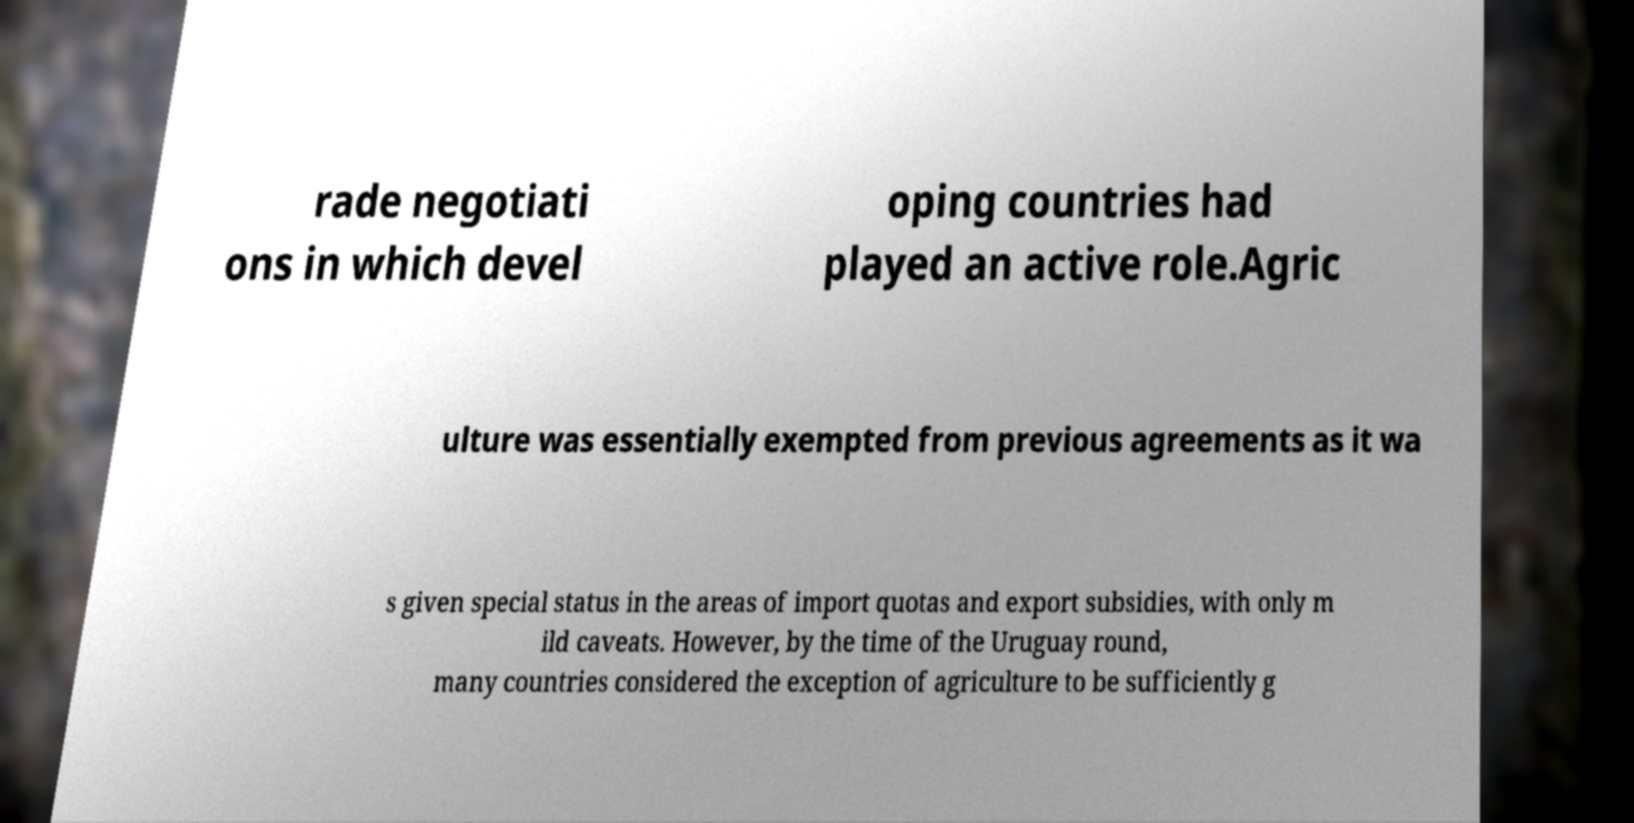I need the written content from this picture converted into text. Can you do that? rade negotiati ons in which devel oping countries had played an active role.Agric ulture was essentially exempted from previous agreements as it wa s given special status in the areas of import quotas and export subsidies, with only m ild caveats. However, by the time of the Uruguay round, many countries considered the exception of agriculture to be sufficiently g 